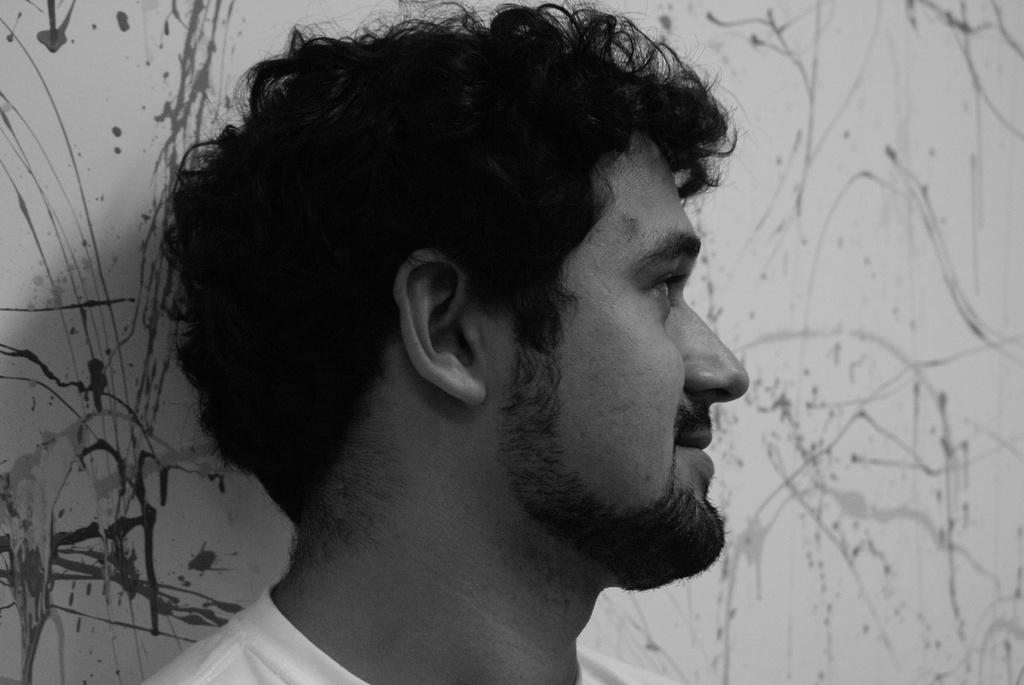What is the color scheme of the image? The image is black and white. Who is present in the image? There is a man in the image. Can you describe the man's appearance? The man has a beard and is wearing a T-shirt. What can be seen on the wall in the image? There is a painting on the wall in the image. How many chickens are visible in the image? There are no chickens present in the image. What type of pollution can be seen in the image? There is no pollution visible in the image. 